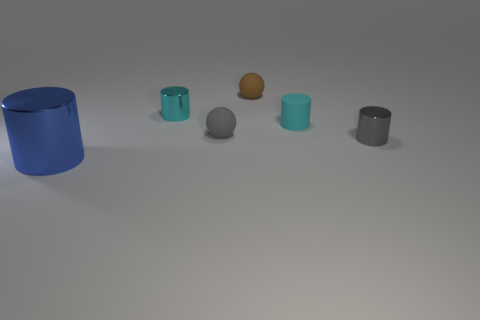What is the size of the gray metallic object that is the same shape as the large blue metallic thing?
Offer a very short reply. Small. How many other brown objects have the same material as the large object?
Your response must be concise. 0. What number of tiny gray metal objects are behind the metal thing in front of the gray shiny thing?
Keep it short and to the point. 1. Are there any gray shiny things behind the brown ball?
Offer a terse response. No. Does the tiny cyan object in front of the cyan metallic cylinder have the same shape as the gray matte object?
Offer a terse response. No. There is a tiny thing that is the same color as the tiny rubber cylinder; what material is it?
Provide a succinct answer. Metal. What number of small shiny cylinders are the same color as the tiny rubber cylinder?
Offer a very short reply. 1. The tiny matte thing behind the cyan cylinder that is in front of the tiny cyan shiny thing is what shape?
Your answer should be compact. Sphere. Is there another blue shiny object of the same shape as the blue object?
Give a very brief answer. No. There is a big thing; does it have the same color as the matte thing that is right of the small brown object?
Provide a short and direct response. No. 